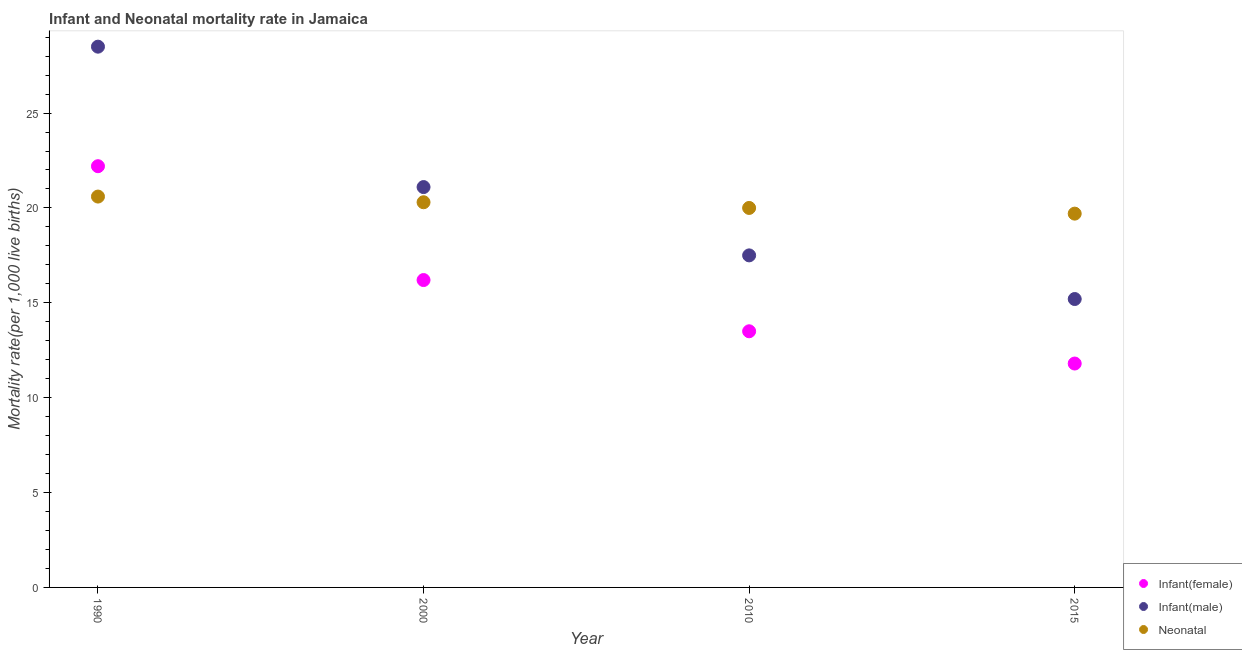How many different coloured dotlines are there?
Provide a short and direct response. 3. What is the infant mortality rate(female) in 2015?
Offer a very short reply. 11.8. In which year was the neonatal mortality rate maximum?
Offer a terse response. 1990. In which year was the infant mortality rate(female) minimum?
Make the answer very short. 2015. What is the total infant mortality rate(male) in the graph?
Make the answer very short. 82.3. What is the difference between the infant mortality rate(male) in 2010 and that in 2015?
Provide a short and direct response. 2.3. What is the difference between the neonatal mortality rate in 2010 and the infant mortality rate(male) in 2000?
Your answer should be compact. -1.1. What is the average neonatal mortality rate per year?
Provide a succinct answer. 20.15. In how many years, is the neonatal mortality rate greater than 10?
Ensure brevity in your answer.  4. What is the ratio of the neonatal mortality rate in 1990 to that in 2010?
Give a very brief answer. 1.03. Is the infant mortality rate(male) in 1990 less than that in 2000?
Your answer should be compact. No. Is the difference between the neonatal mortality rate in 2000 and 2015 greater than the difference between the infant mortality rate(female) in 2000 and 2015?
Your answer should be very brief. No. What is the difference between the highest and the second highest neonatal mortality rate?
Your answer should be compact. 0.3. What is the difference between the highest and the lowest infant mortality rate(female)?
Your response must be concise. 10.4. Is the infant mortality rate(female) strictly less than the infant mortality rate(male) over the years?
Your answer should be compact. Yes. What is the difference between two consecutive major ticks on the Y-axis?
Make the answer very short. 5. Does the graph contain any zero values?
Offer a very short reply. No. How are the legend labels stacked?
Provide a short and direct response. Vertical. What is the title of the graph?
Ensure brevity in your answer.  Infant and Neonatal mortality rate in Jamaica. Does "Resident buildings and public services" appear as one of the legend labels in the graph?
Ensure brevity in your answer.  No. What is the label or title of the X-axis?
Keep it short and to the point. Year. What is the label or title of the Y-axis?
Provide a succinct answer. Mortality rate(per 1,0 live births). What is the Mortality rate(per 1,000 live births) of Infant(female) in 1990?
Provide a succinct answer. 22.2. What is the Mortality rate(per 1,000 live births) of Neonatal  in 1990?
Offer a very short reply. 20.6. What is the Mortality rate(per 1,000 live births) in Infant(female) in 2000?
Ensure brevity in your answer.  16.2. What is the Mortality rate(per 1,000 live births) of Infant(male) in 2000?
Your answer should be very brief. 21.1. What is the Mortality rate(per 1,000 live births) in Neonatal  in 2000?
Provide a succinct answer. 20.3. What is the Mortality rate(per 1,000 live births) in Infant(female) in 2010?
Your answer should be compact. 13.5. What is the Mortality rate(per 1,000 live births) of Infant(male) in 2010?
Ensure brevity in your answer.  17.5. What is the Mortality rate(per 1,000 live births) of Neonatal  in 2010?
Keep it short and to the point. 20. What is the Mortality rate(per 1,000 live births) in Infant(male) in 2015?
Provide a short and direct response. 15.2. Across all years, what is the maximum Mortality rate(per 1,000 live births) in Neonatal ?
Offer a terse response. 20.6. Across all years, what is the minimum Mortality rate(per 1,000 live births) in Neonatal ?
Ensure brevity in your answer.  19.7. What is the total Mortality rate(per 1,000 live births) in Infant(female) in the graph?
Offer a terse response. 63.7. What is the total Mortality rate(per 1,000 live births) in Infant(male) in the graph?
Offer a terse response. 82.3. What is the total Mortality rate(per 1,000 live births) of Neonatal  in the graph?
Give a very brief answer. 80.6. What is the difference between the Mortality rate(per 1,000 live births) of Infant(female) in 1990 and that in 2000?
Offer a terse response. 6. What is the difference between the Mortality rate(per 1,000 live births) in Infant(male) in 1990 and that in 2000?
Make the answer very short. 7.4. What is the difference between the Mortality rate(per 1,000 live births) in Neonatal  in 1990 and that in 2000?
Offer a terse response. 0.3. What is the difference between the Mortality rate(per 1,000 live births) in Infant(female) in 1990 and that in 2010?
Keep it short and to the point. 8.7. What is the difference between the Mortality rate(per 1,000 live births) of Infant(female) in 1990 and that in 2015?
Your answer should be compact. 10.4. What is the difference between the Mortality rate(per 1,000 live births) of Infant(male) in 1990 and that in 2015?
Give a very brief answer. 13.3. What is the difference between the Mortality rate(per 1,000 live births) of Neonatal  in 1990 and that in 2015?
Provide a short and direct response. 0.9. What is the difference between the Mortality rate(per 1,000 live births) of Infant(female) in 2000 and that in 2010?
Offer a very short reply. 2.7. What is the difference between the Mortality rate(per 1,000 live births) in Infant(female) in 2000 and that in 2015?
Offer a very short reply. 4.4. What is the difference between the Mortality rate(per 1,000 live births) in Neonatal  in 2000 and that in 2015?
Your response must be concise. 0.6. What is the difference between the Mortality rate(per 1,000 live births) of Infant(male) in 2010 and that in 2015?
Your answer should be very brief. 2.3. What is the difference between the Mortality rate(per 1,000 live births) of Neonatal  in 2010 and that in 2015?
Your answer should be very brief. 0.3. What is the difference between the Mortality rate(per 1,000 live births) in Infant(female) in 1990 and the Mortality rate(per 1,000 live births) in Infant(male) in 2000?
Ensure brevity in your answer.  1.1. What is the difference between the Mortality rate(per 1,000 live births) of Infant(female) in 1990 and the Mortality rate(per 1,000 live births) of Neonatal  in 2000?
Keep it short and to the point. 1.9. What is the difference between the Mortality rate(per 1,000 live births) of Infant(male) in 1990 and the Mortality rate(per 1,000 live births) of Neonatal  in 2000?
Provide a succinct answer. 8.2. What is the difference between the Mortality rate(per 1,000 live births) of Infant(female) in 1990 and the Mortality rate(per 1,000 live births) of Infant(male) in 2010?
Your answer should be compact. 4.7. What is the difference between the Mortality rate(per 1,000 live births) of Infant(male) in 1990 and the Mortality rate(per 1,000 live births) of Neonatal  in 2010?
Offer a terse response. 8.5. What is the difference between the Mortality rate(per 1,000 live births) in Infant(male) in 1990 and the Mortality rate(per 1,000 live births) in Neonatal  in 2015?
Your answer should be compact. 8.8. What is the difference between the Mortality rate(per 1,000 live births) of Infant(female) in 2000 and the Mortality rate(per 1,000 live births) of Infant(male) in 2010?
Offer a very short reply. -1.3. What is the difference between the Mortality rate(per 1,000 live births) of Infant(female) in 2000 and the Mortality rate(per 1,000 live births) of Neonatal  in 2010?
Ensure brevity in your answer.  -3.8. What is the difference between the Mortality rate(per 1,000 live births) of Infant(female) in 2000 and the Mortality rate(per 1,000 live births) of Infant(male) in 2015?
Make the answer very short. 1. What is the difference between the Mortality rate(per 1,000 live births) of Infant(female) in 2000 and the Mortality rate(per 1,000 live births) of Neonatal  in 2015?
Offer a very short reply. -3.5. What is the difference between the Mortality rate(per 1,000 live births) of Infant(male) in 2000 and the Mortality rate(per 1,000 live births) of Neonatal  in 2015?
Give a very brief answer. 1.4. What is the average Mortality rate(per 1,000 live births) in Infant(female) per year?
Your answer should be very brief. 15.93. What is the average Mortality rate(per 1,000 live births) of Infant(male) per year?
Your answer should be compact. 20.57. What is the average Mortality rate(per 1,000 live births) in Neonatal  per year?
Offer a very short reply. 20.15. In the year 1990, what is the difference between the Mortality rate(per 1,000 live births) of Infant(female) and Mortality rate(per 1,000 live births) of Infant(male)?
Provide a succinct answer. -6.3. In the year 2000, what is the difference between the Mortality rate(per 1,000 live births) of Infant(male) and Mortality rate(per 1,000 live births) of Neonatal ?
Make the answer very short. 0.8. In the year 2010, what is the difference between the Mortality rate(per 1,000 live births) in Infant(female) and Mortality rate(per 1,000 live births) in Infant(male)?
Provide a short and direct response. -4. In the year 2015, what is the difference between the Mortality rate(per 1,000 live births) in Infant(male) and Mortality rate(per 1,000 live births) in Neonatal ?
Your response must be concise. -4.5. What is the ratio of the Mortality rate(per 1,000 live births) of Infant(female) in 1990 to that in 2000?
Keep it short and to the point. 1.37. What is the ratio of the Mortality rate(per 1,000 live births) in Infant(male) in 1990 to that in 2000?
Offer a terse response. 1.35. What is the ratio of the Mortality rate(per 1,000 live births) in Neonatal  in 1990 to that in 2000?
Your answer should be compact. 1.01. What is the ratio of the Mortality rate(per 1,000 live births) in Infant(female) in 1990 to that in 2010?
Give a very brief answer. 1.64. What is the ratio of the Mortality rate(per 1,000 live births) of Infant(male) in 1990 to that in 2010?
Provide a succinct answer. 1.63. What is the ratio of the Mortality rate(per 1,000 live births) in Infant(female) in 1990 to that in 2015?
Give a very brief answer. 1.88. What is the ratio of the Mortality rate(per 1,000 live births) in Infant(male) in 1990 to that in 2015?
Your answer should be very brief. 1.88. What is the ratio of the Mortality rate(per 1,000 live births) in Neonatal  in 1990 to that in 2015?
Offer a very short reply. 1.05. What is the ratio of the Mortality rate(per 1,000 live births) in Infant(female) in 2000 to that in 2010?
Offer a terse response. 1.2. What is the ratio of the Mortality rate(per 1,000 live births) in Infant(male) in 2000 to that in 2010?
Offer a terse response. 1.21. What is the ratio of the Mortality rate(per 1,000 live births) of Infant(female) in 2000 to that in 2015?
Provide a succinct answer. 1.37. What is the ratio of the Mortality rate(per 1,000 live births) in Infant(male) in 2000 to that in 2015?
Offer a terse response. 1.39. What is the ratio of the Mortality rate(per 1,000 live births) in Neonatal  in 2000 to that in 2015?
Your response must be concise. 1.03. What is the ratio of the Mortality rate(per 1,000 live births) of Infant(female) in 2010 to that in 2015?
Make the answer very short. 1.14. What is the ratio of the Mortality rate(per 1,000 live births) in Infant(male) in 2010 to that in 2015?
Provide a succinct answer. 1.15. What is the ratio of the Mortality rate(per 1,000 live births) of Neonatal  in 2010 to that in 2015?
Provide a short and direct response. 1.02. What is the difference between the highest and the second highest Mortality rate(per 1,000 live births) of Infant(female)?
Your response must be concise. 6. What is the difference between the highest and the second highest Mortality rate(per 1,000 live births) of Infant(male)?
Ensure brevity in your answer.  7.4. What is the difference between the highest and the lowest Mortality rate(per 1,000 live births) of Infant(female)?
Give a very brief answer. 10.4. 